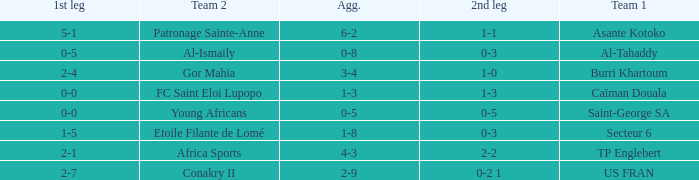Which team lost 0-3 and 0-5? Al-Tahaddy. 